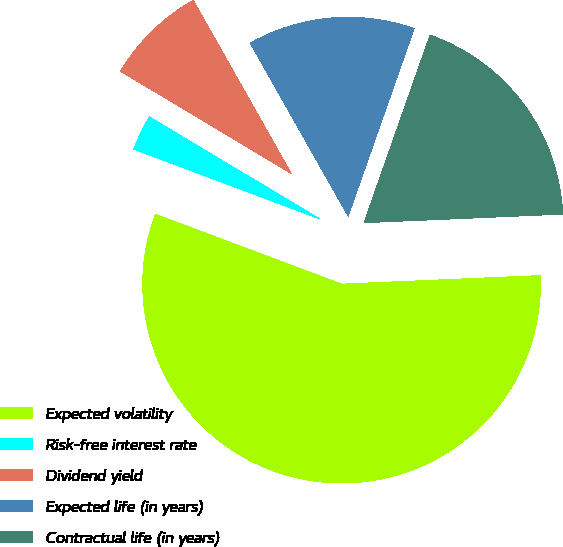<chart> <loc_0><loc_0><loc_500><loc_500><pie_chart><fcel>Expected volatility<fcel>Risk-free interest rate<fcel>Dividend yield<fcel>Expected life (in years)<fcel>Contractual life (in years)<nl><fcel>56.4%<fcel>2.87%<fcel>8.22%<fcel>13.58%<fcel>18.93%<nl></chart> 